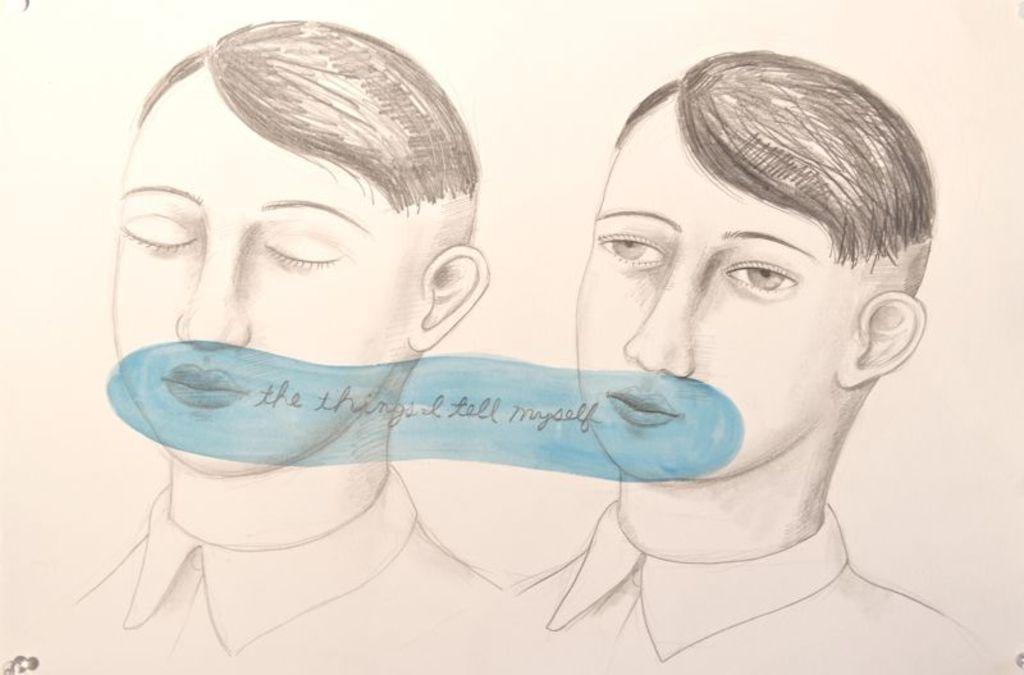What is depicted in the image? The image contains a pencil drawing of two persons. What color is the object in the image? There is a blue color object in the image. What is happening with the blue color object? Something is returned on the blue color object. What type of underwear is being worn by the persons in the image? There is no information about underwear in the image, as it only contains a pencil drawing of two persons and a blue color object. 